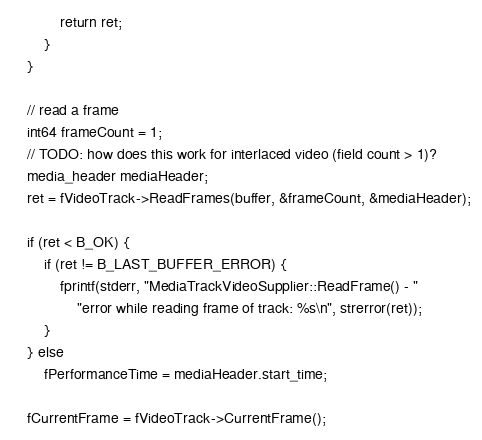<code> <loc_0><loc_0><loc_500><loc_500><_C++_>			return ret;
		}
	}

	// read a frame
	int64 frameCount = 1;
	// TODO: how does this work for interlaced video (field count > 1)?
	media_header mediaHeader;
	ret = fVideoTrack->ReadFrames(buffer, &frameCount, &mediaHeader);

	if (ret < B_OK) {
		if (ret != B_LAST_BUFFER_ERROR) {
			fprintf(stderr, "MediaTrackVideoSupplier::ReadFrame() - "
				"error while reading frame of track: %s\n", strerror(ret));
		}
	} else
		fPerformanceTime = mediaHeader.start_time;

	fCurrentFrame = fVideoTrack->CurrentFrame();</code> 